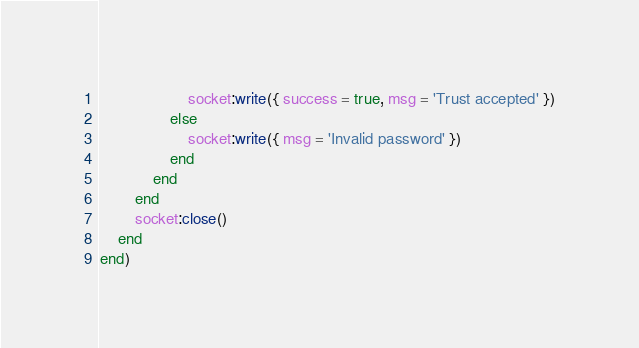Convert code to text. <code><loc_0><loc_0><loc_500><loc_500><_Lua_>					socket:write({ success = true, msg = 'Trust accepted' })
				else
					socket:write({ msg = 'Invalid password' })
				end
			end
		end
		socket:close()
	end
end)
</code> 